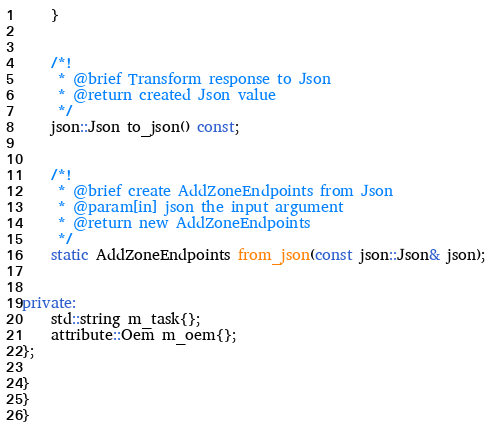<code> <loc_0><loc_0><loc_500><loc_500><_C++_>    }


    /*!
     * @brief Transform response to Json
     * @return created Json value
     */
    json::Json to_json() const;


    /*!
     * @brief create AddZoneEndpoints from Json
     * @param[in] json the input argument
     * @return new AddZoneEndpoints
     */
    static AddZoneEndpoints from_json(const json::Json& json);


private:
    std::string m_task{};
    attribute::Oem m_oem{};
};

}
}
}
</code> 